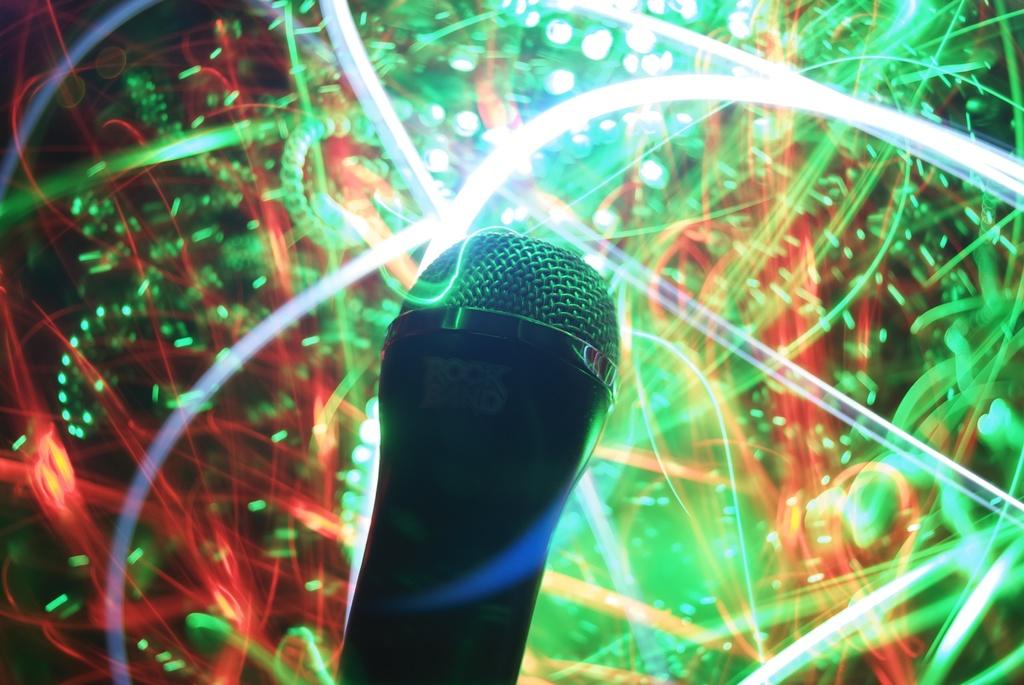What is the main object in the center of the image? There is a mic in the center of the image. What can be seen in the background of the image? There are lights visible in the background of the image. What type of horn can be seen on the mic in the image? There is no horn present on the mic in the image. What kind of competition is taking place in the image? There is no competition present in the image; it only features a mic and lights in the background. 